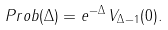<formula> <loc_0><loc_0><loc_500><loc_500>P r o b ( \Delta ) = e ^ { - \Delta } \, V _ { \Delta - 1 } ( 0 ) .</formula> 